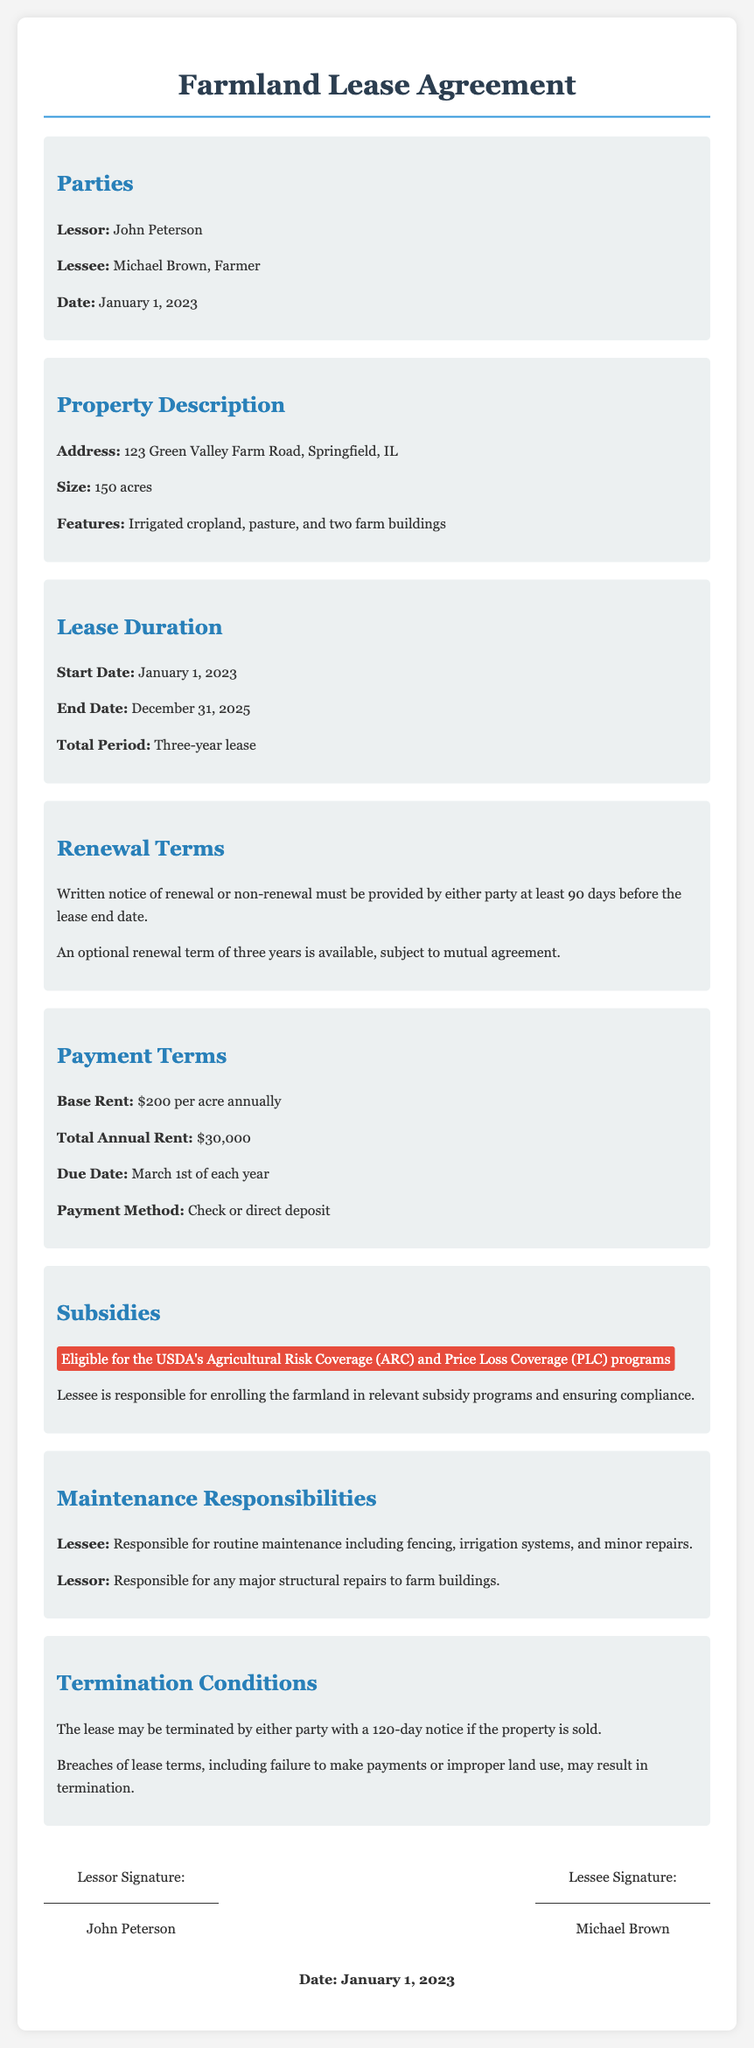What is the start date of the lease? The start date of the lease is mentioned in the Lease Duration section of the document.
Answer: January 1, 2023 What is the end date of the lease? The end date of the lease is specified in the Lease Duration section of the document.
Answer: December 31, 2025 What is the total period of the lease? The lease duration is explicitly stated as a three-year lease.
Answer: Three-year lease How much notice is required for renewal or non-renewal? The renewal terms specify the required notice period for either party.
Answer: 90 days Is there an optional renewal term available? The renewal terms indicate whether a renewal is available and any conditions.
Answer: Yes, three years What is the annual rent per acre? The Payment Terms section states the base rent amount.
Answer: $200 per acre What are the subsidies listed for the farmland? The Subsidies section mentions specific programs that the farmland is eligible for.
Answer: USDA's Agricultural Risk Coverage (ARC) and Price Loss Coverage (PLC) Who is responsible for major structural repairs? The Maintenance Responsibilities section differentiates responsibilities between the lessor and lessee.
Answer: Lessor What is the notice period for termination of the lease? The Termination Conditions section specifies the required notice for termination in certain cases.
Answer: 120 days 